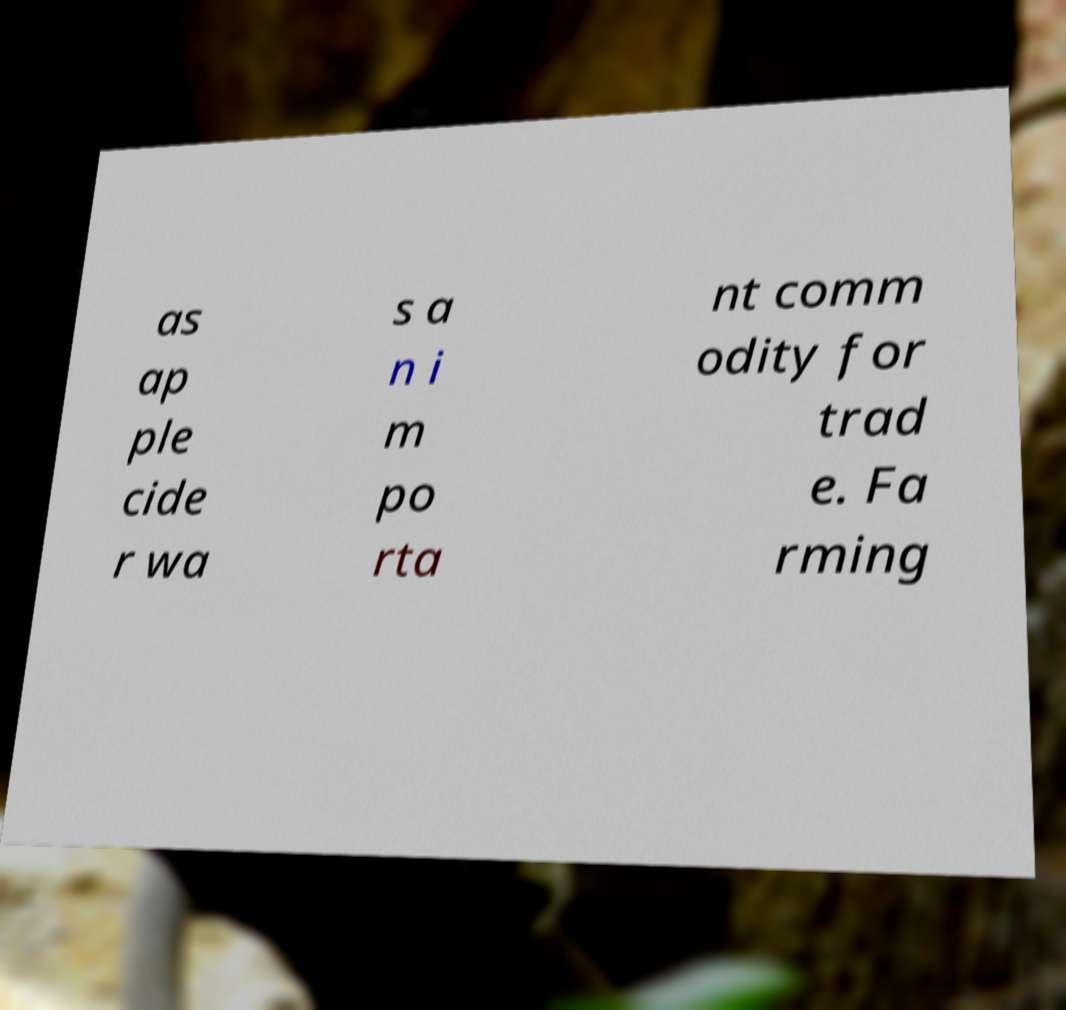Could you extract and type out the text from this image? as ap ple cide r wa s a n i m po rta nt comm odity for trad e. Fa rming 